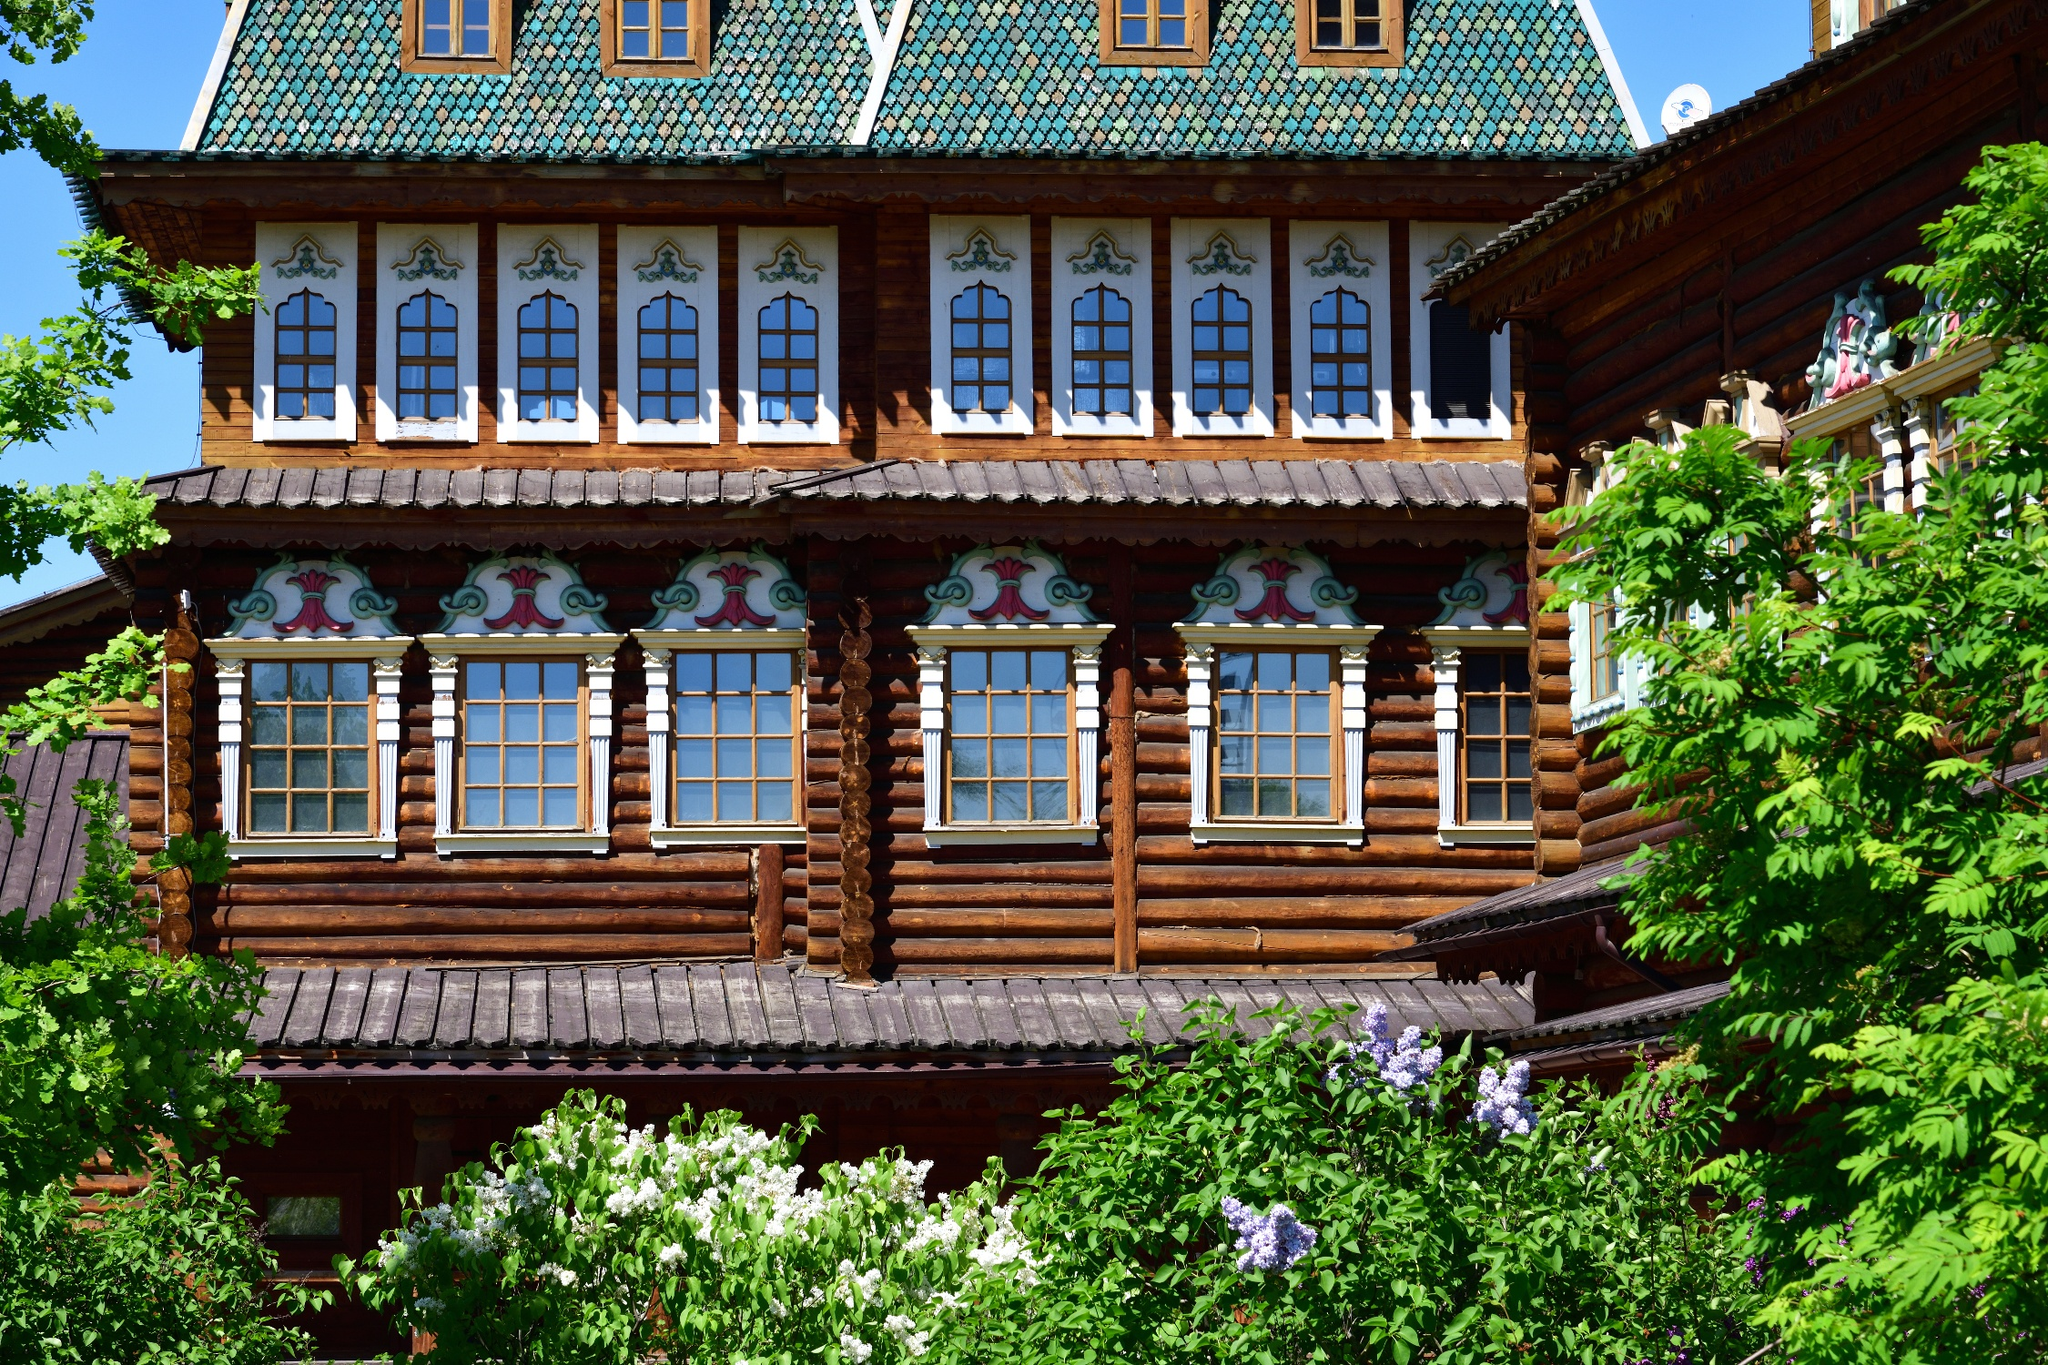What do you see happening in this image? The image beautifully portrays the Wooden Palace of Tsar Alexei Mikhailovich in Kolomenskoye, near Moscow, Russia. This palace, constructed entirely from wood, exudes a regal and historical aura set against lush greenery. The rich green roof complements the muted brown of the timber, accentuated by the windows adorned with vibrant decorative patterns. Trees and blooming bushes surrounding the palace add to its picturesque quality, highlighting the blend of man-made craftsmanship and natural beauty. This place is not only a visual treat but a significant historical artifact, representing traditional Russian wooden architecture and the artistic endeavors of the era. 